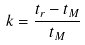<formula> <loc_0><loc_0><loc_500><loc_500>k = \frac { t _ { r } - t _ { M } } { t _ { M } }</formula> 